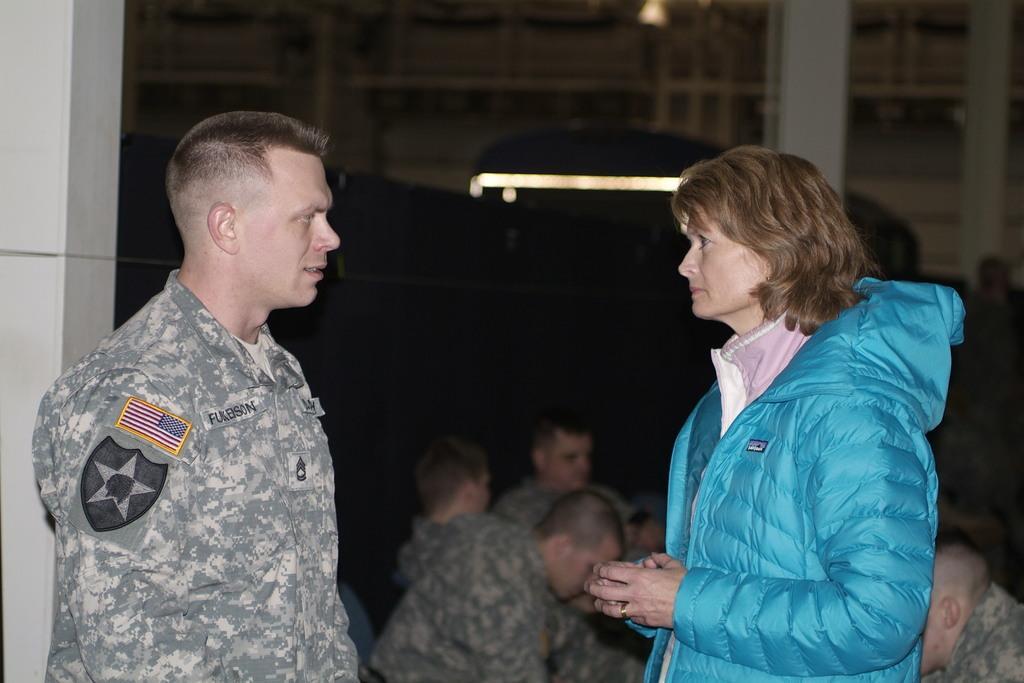Could you give a brief overview of what you see in this image? In this image I can see on the left side there is a man in army dress. On the right side there is a woman, she wore blue color coat. In the middle few people are sitting. 